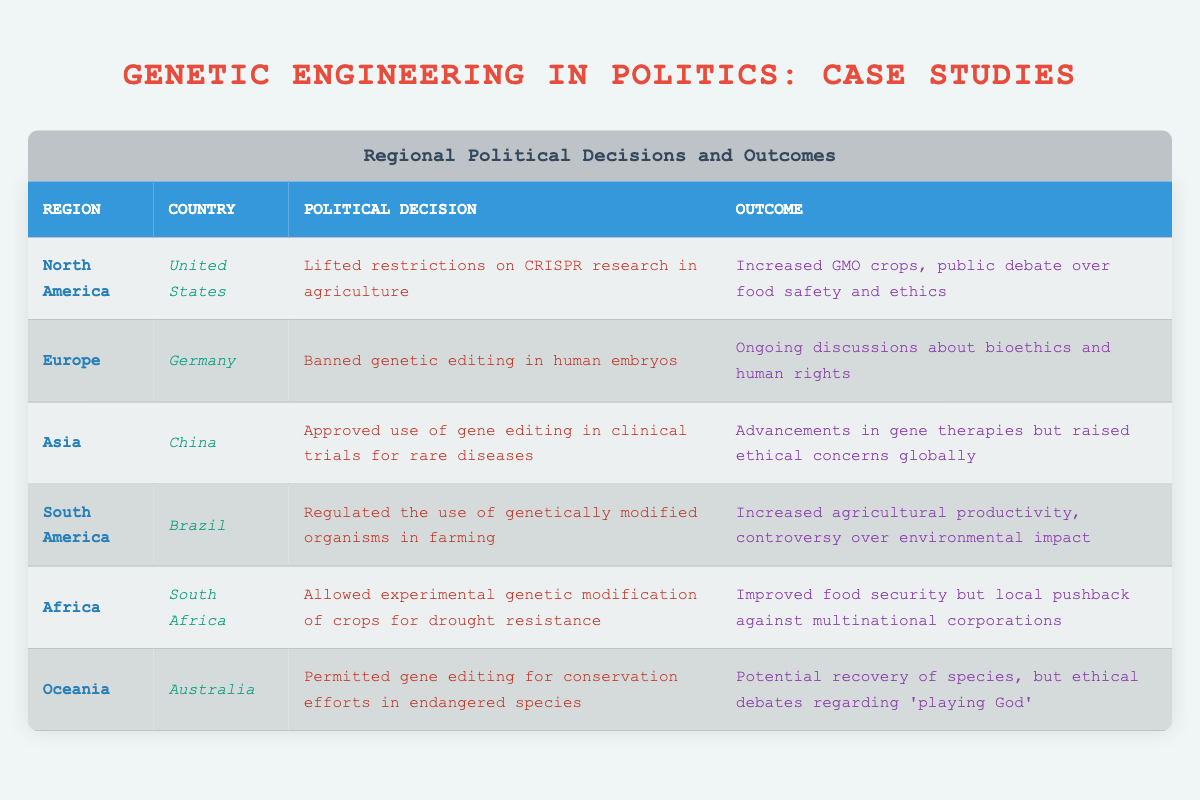What political decision did Germany make regarding genetic editing? The table specifies that Germany banned genetic editing in human embryos.
Answer: Banned genetic editing in human embryos Which country allowed experimental genetic modification of crops for drought resistance? According to the table, South Africa is the country that allowed experimental genetic modification of crops for drought resistance.
Answer: South Africa What is the outcome of the United States lifting restrictions on CRISPR research in agriculture? The outcome specified in the table for the U.S. decision is increased GMO crops and public debate over food safety and ethics.
Answer: Increased GMO crops, public debate over food safety and ethics How many regions have seen an outcome involving public debate over ethical implications? Two regions show outcomes involving public debate over ethical implications: North America (U.S.) and Oceania (Australia). Hence, there are 2 regions.
Answer: 2 Did Brazil ban genetic modifications in farming? The table indicates that Brazil regulated the use of genetically modified organisms rather than banning them, which implies that it is false that Brazil banned genetic modifications.
Answer: No Which region's political decision led to an improvement in food security? The table shows that South Africa's political decision allowed for experimental genetic modification of crops, leading to improved food security.
Answer: Africa In which region is there ongoing discussion about bioethics and human rights? The table clearly states that there are ongoing discussions about bioethics and human rights in Germany, which is located in Europe.
Answer: Europe What is the average number of regions that led to ethical concerns or debates? The regions with ethical concerns are North America (U.S.), Asia (China), Oceania (Australia), and Africa (South Africa). The average number is 4 regions divided by 5 total regions giving an average of 0.8 regional discussions per country with ethical concerns.
Answer: 0.8 Which political decision had the specific outcome of raising ethical concerns globally? The table indicates that the approval of gene editing in clinical trials for rare diseases in China raised ethical concerns globally.
Answer: Approved use of gene editing in clinical trials for rare diseases in China 